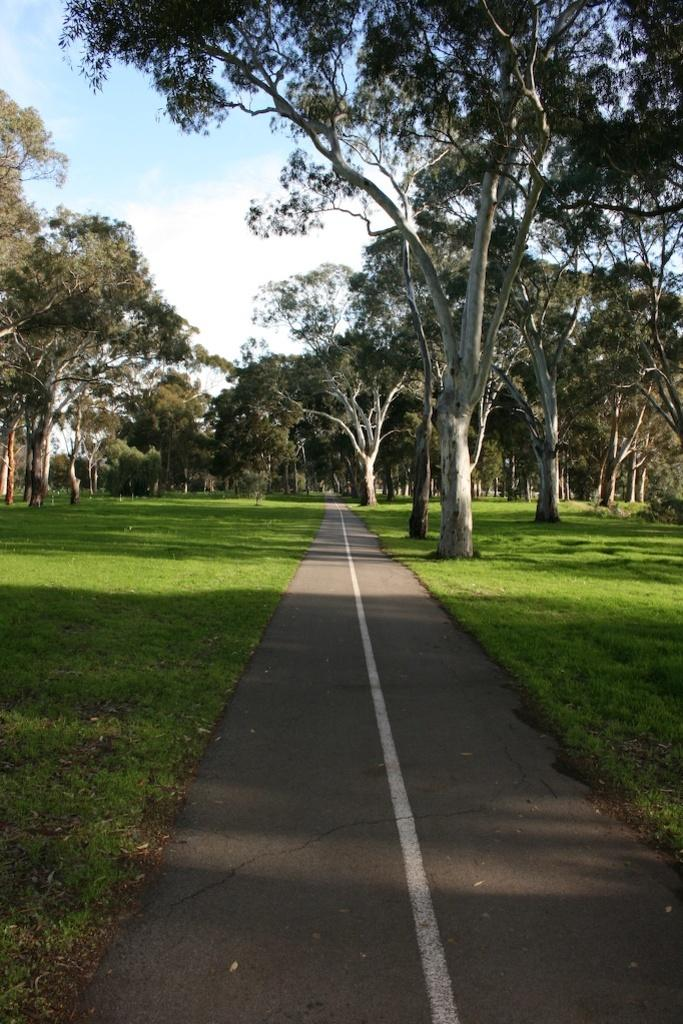What is the main feature of the image? There is a road in the image. What type of vegetation can be seen in the image? There are trees and grass in the image. What is visible in the background of the image? The sky is visible in the background of the image. What can be observed in the sky? Clouds are present in the sky. Where is the cobweb located in the image? There is no cobweb present in the image. How many oranges are visible in the image? There are no oranges present in the image. 